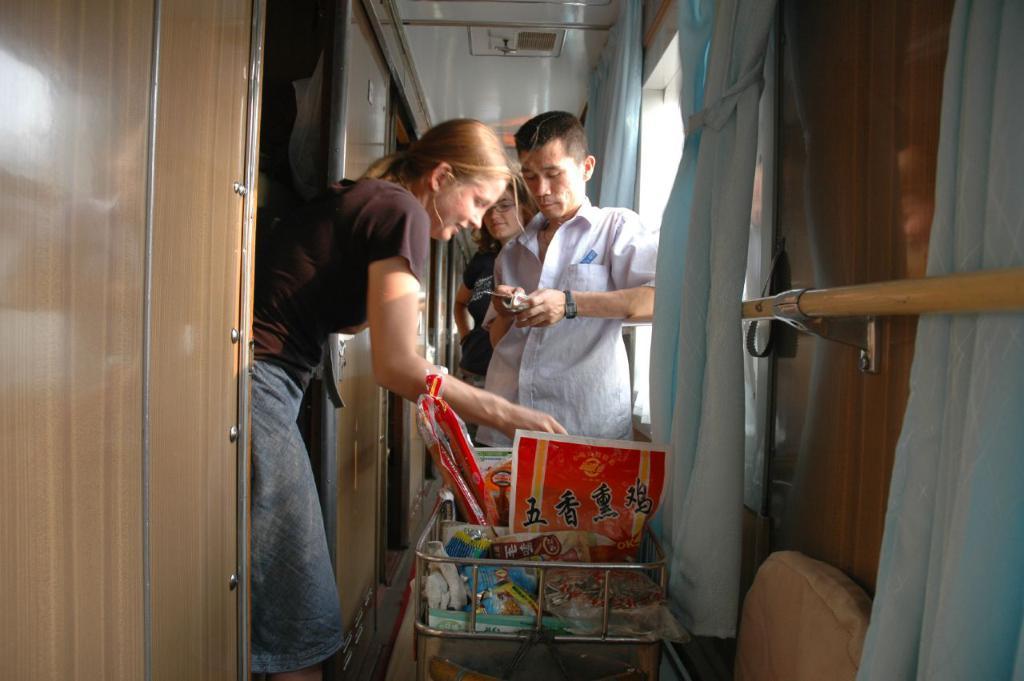Please provide a concise description of this image. In this image we can see some people standing. In that a man is holding a cellphone and a woman is holding a trolley. We can also see windows with curtains, wall, door and a roof. 